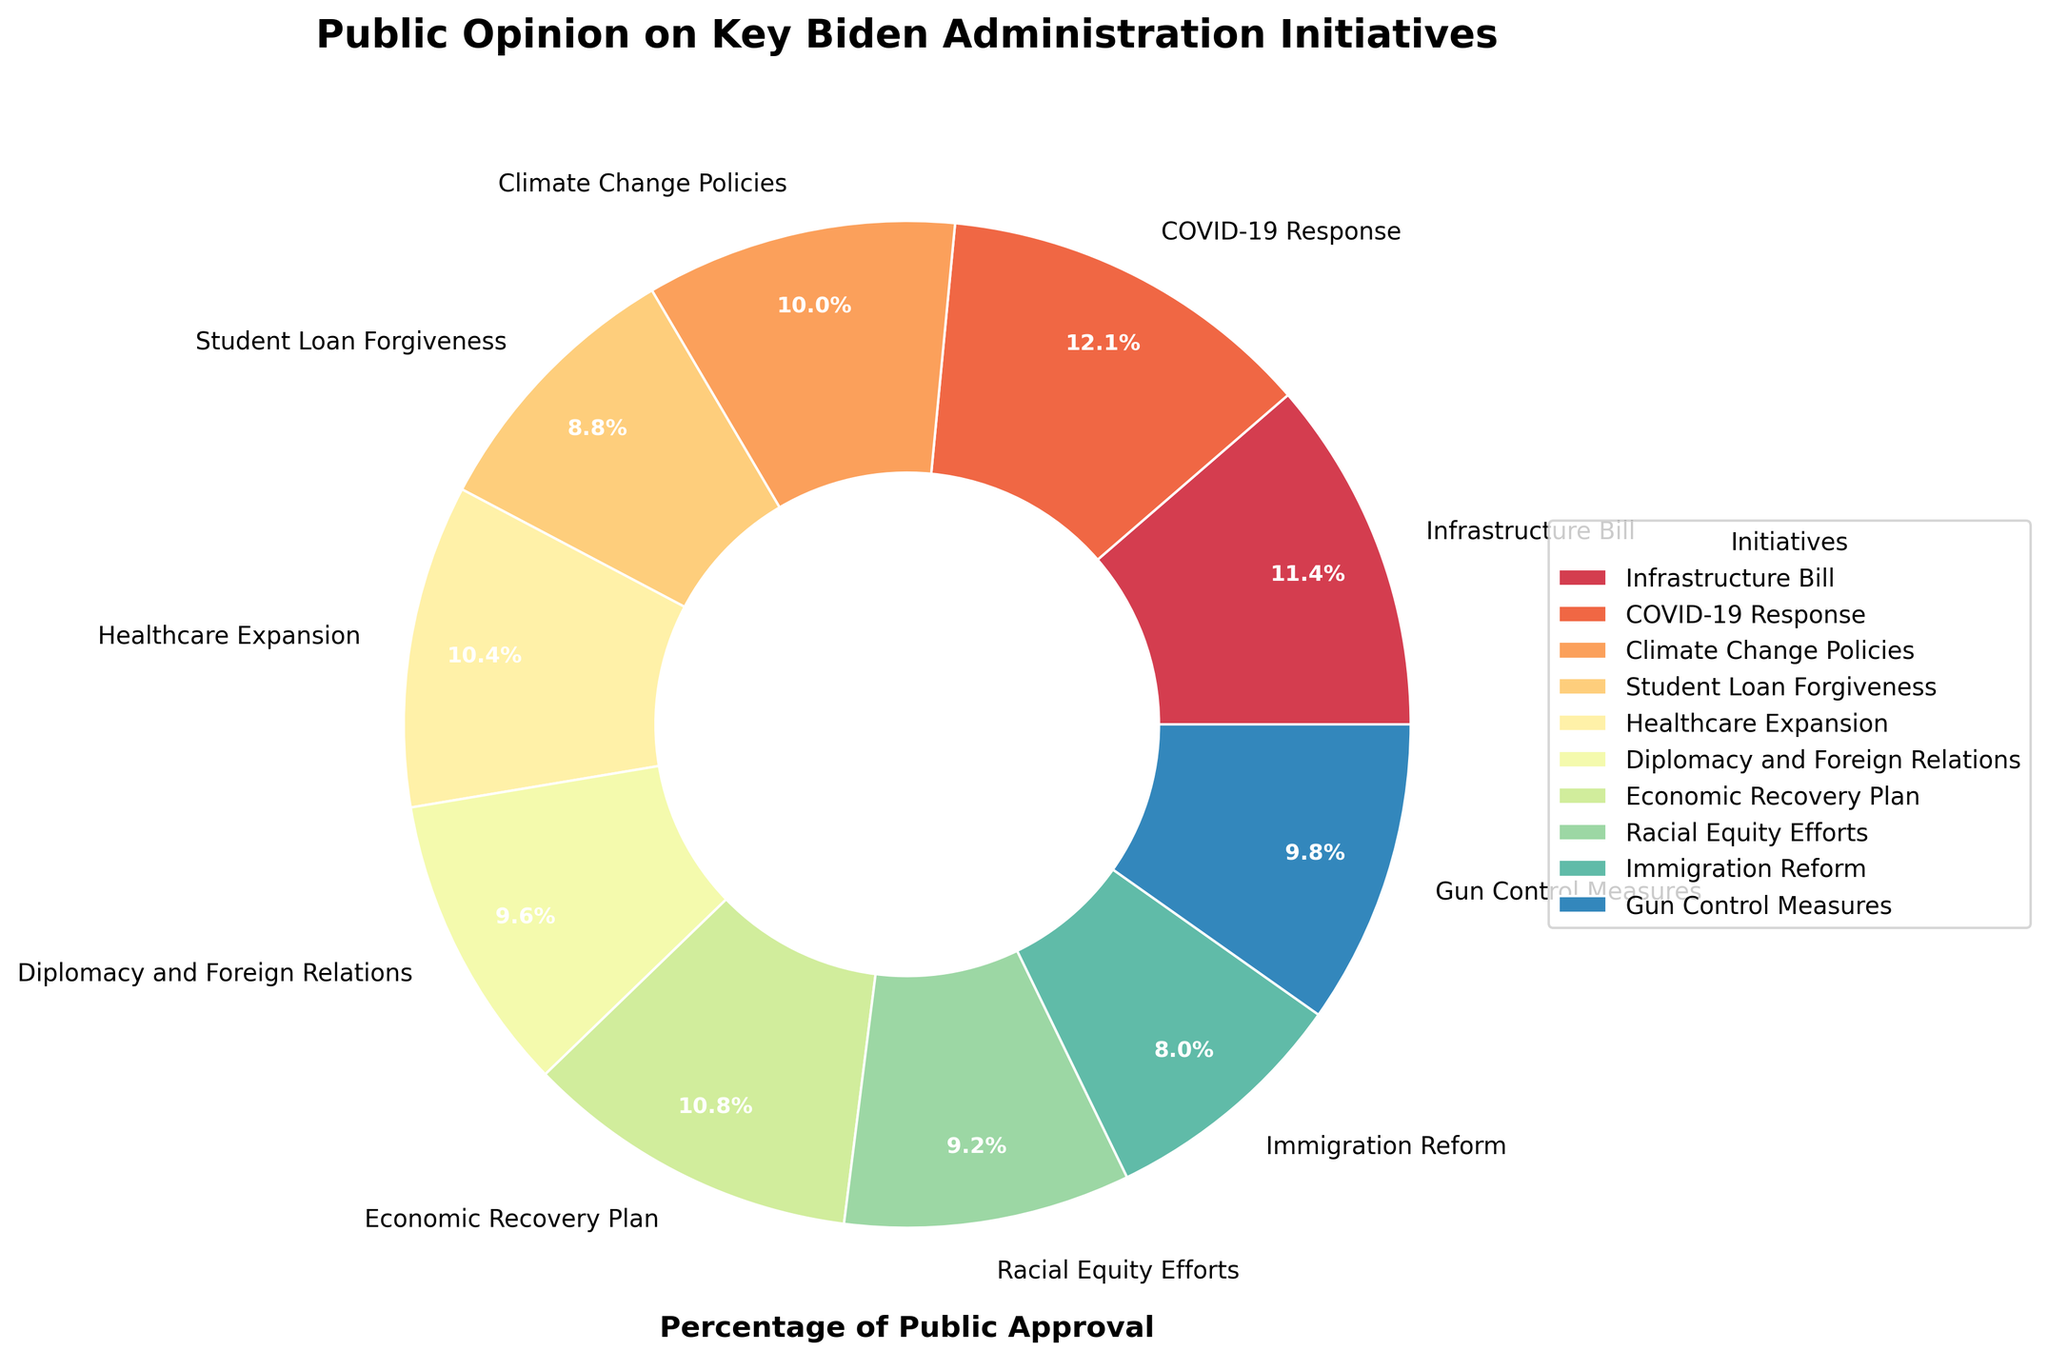What percentage of people approve of the Infrastructure Bill? The pie chart shows the percentage of public approval for various Biden administration initiatives. The section labeled "Infrastructure Bill" has an approval percentage indicated by the corresponding slice of the pie.
Answer: 58% Which initiative has the highest public approval, and what is the percentage? To determine the initiative with the highest approval, compare the percentage values presented on each slice of the pie chart. The slice with the highest value indicates the highest public approval.
Answer: COVID-19 Response, 62% What is the combined approval percentage for Climate Change Policies and Healthcare Expansion? To find the combined approval percentage, simply sum the approval percentages for "Climate Change Policies" and "Healthcare Expansion" as shown in the pie chart.
Answer: 51% + 53% = 104% Is the approval percentage for Student Loan Forgiveness higher than that for Immigration Reform? To compare these two initiatives, look at their individual approval percentages in the pie chart. Compare 45% (Student Loan Forgiveness) and 41% (Immigration Reform).
Answer: Yes Which initiatives have approval percentages between 50% and 60%? To identify the initiatives with approval percentages between 50% and 60%, review each section of the pie chart and note which slices fall within this range.
Answer: Climate Change Policies (51%), Healthcare Expansion (53%), Gun Control Measures (50%) Which has a lower approval percentage: Racial Equity Efforts or Gun Control Measures? Compare the approval percentages of Racial Equity Efforts (47%) and Gun Control Measures (50%) as shown in the pie chart. Determine which value is lower.
Answer: Racial Equity Efforts What is the difference in approval percentage between Economic Recovery Plan and Immigration Reform? To find the difference, subtract the approval percentage of Immigration Reform (41%) from that of Economic Recovery Plan (55%).
Answer: 55% - 41% = 14% Which initiative's approval percentage is closest to 50%? Identify the approval percentages around 50% in the pie chart and determine which one is closest.
Answer: Gun Control Measures (50%) 